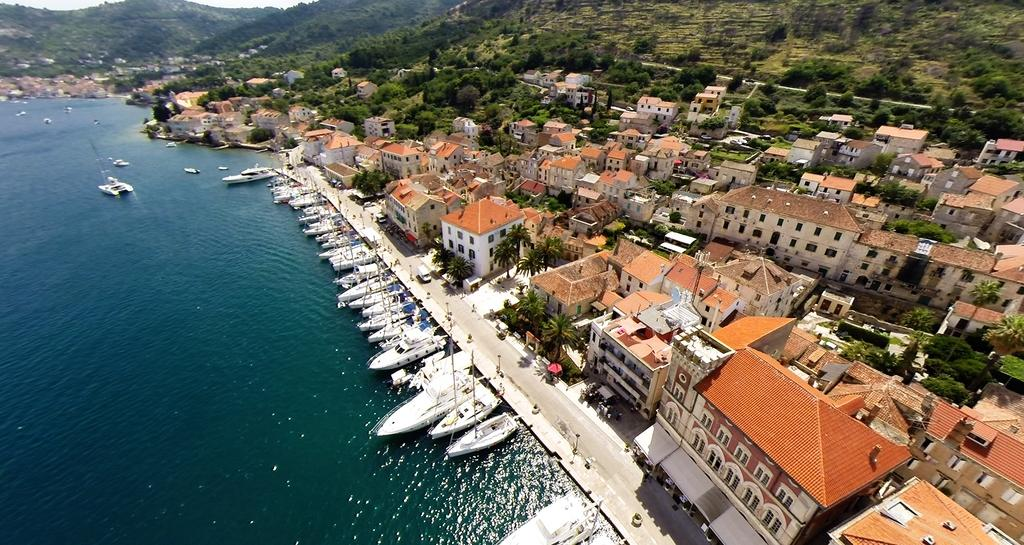What is on the water in the image? There are boats on the water in the image. What structures are near the water in the image? There are buildings near the water in the image. What type of vegetation is near the water in the image? There are trees near the water in the image. What can be seen in the distance in the image? There are hills visible in the background of the image. What type of beds can be seen in the image? There are no beds present in the image; it features boats on the water, buildings, trees, and hills in the background. Can you describe the haircut of the person in the image? There are no people present in the image, so it is not possible to describe a haircut. 